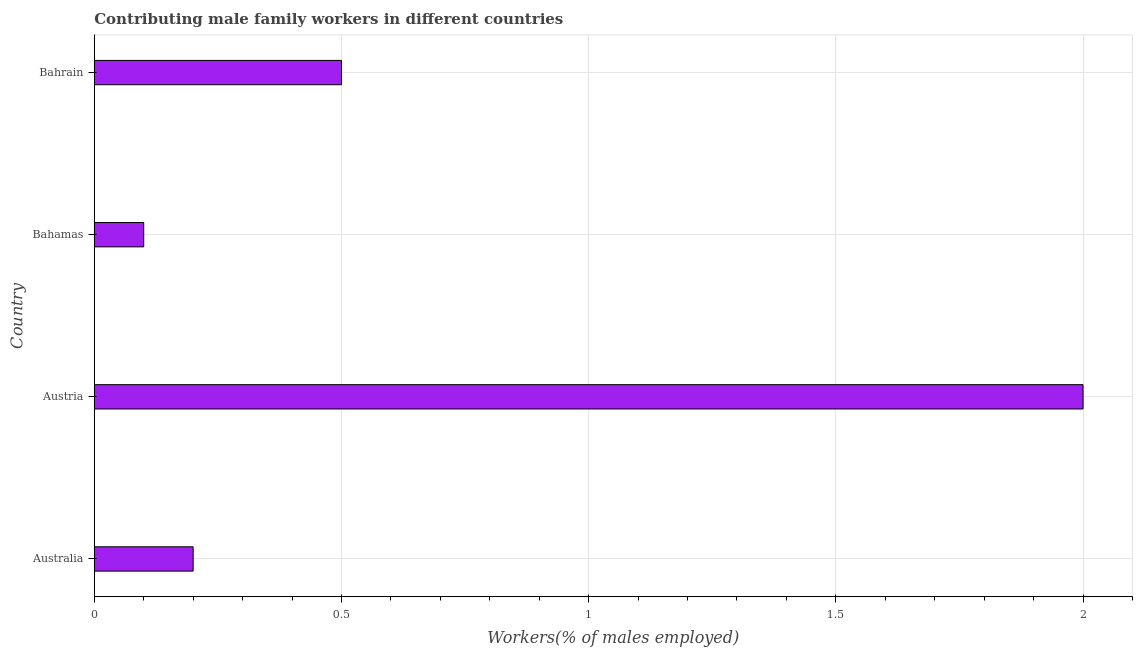Does the graph contain grids?
Your answer should be compact. Yes. What is the title of the graph?
Your answer should be very brief. Contributing male family workers in different countries. What is the label or title of the X-axis?
Your answer should be compact. Workers(% of males employed). What is the label or title of the Y-axis?
Keep it short and to the point. Country. What is the contributing male family workers in Bahamas?
Provide a succinct answer. 0.1. Across all countries, what is the maximum contributing male family workers?
Offer a terse response. 2. Across all countries, what is the minimum contributing male family workers?
Provide a short and direct response. 0.1. In which country was the contributing male family workers minimum?
Provide a short and direct response. Bahamas. What is the sum of the contributing male family workers?
Keep it short and to the point. 2.8. What is the median contributing male family workers?
Offer a terse response. 0.35. What is the ratio of the contributing male family workers in Bahamas to that in Bahrain?
Your response must be concise. 0.2. Is the contributing male family workers in Australia less than that in Bahamas?
Offer a terse response. No. Is the difference between the contributing male family workers in Austria and Bahrain greater than the difference between any two countries?
Provide a succinct answer. No. What is the difference between the highest and the second highest contributing male family workers?
Offer a very short reply. 1.5. Is the sum of the contributing male family workers in Australia and Bahrain greater than the maximum contributing male family workers across all countries?
Keep it short and to the point. No. In how many countries, is the contributing male family workers greater than the average contributing male family workers taken over all countries?
Your response must be concise. 1. Are the values on the major ticks of X-axis written in scientific E-notation?
Ensure brevity in your answer.  No. What is the Workers(% of males employed) in Australia?
Make the answer very short. 0.2. What is the Workers(% of males employed) in Bahamas?
Offer a very short reply. 0.1. What is the Workers(% of males employed) of Bahrain?
Keep it short and to the point. 0.5. What is the difference between the Workers(% of males employed) in Australia and Austria?
Keep it short and to the point. -1.8. What is the difference between the Workers(% of males employed) in Australia and Bahrain?
Your answer should be compact. -0.3. What is the difference between the Workers(% of males employed) in Austria and Bahrain?
Offer a terse response. 1.5. What is the ratio of the Workers(% of males employed) in Australia to that in Bahrain?
Your answer should be very brief. 0.4. What is the ratio of the Workers(% of males employed) in Bahamas to that in Bahrain?
Provide a succinct answer. 0.2. 